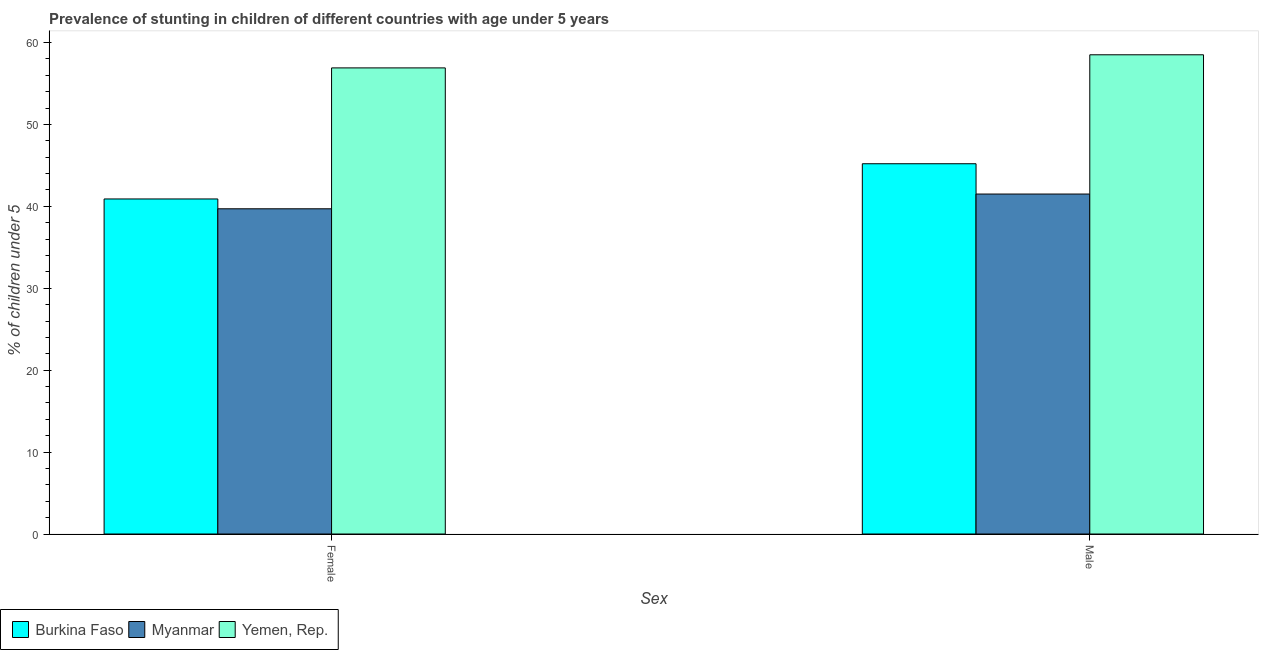How many different coloured bars are there?
Give a very brief answer. 3. Are the number of bars per tick equal to the number of legend labels?
Give a very brief answer. Yes. How many bars are there on the 1st tick from the left?
Give a very brief answer. 3. How many bars are there on the 1st tick from the right?
Provide a succinct answer. 3. What is the percentage of stunted male children in Yemen, Rep.?
Ensure brevity in your answer.  58.5. Across all countries, what is the maximum percentage of stunted female children?
Offer a very short reply. 56.9. Across all countries, what is the minimum percentage of stunted male children?
Offer a terse response. 41.5. In which country was the percentage of stunted female children maximum?
Offer a terse response. Yemen, Rep. In which country was the percentage of stunted female children minimum?
Make the answer very short. Myanmar. What is the total percentage of stunted female children in the graph?
Make the answer very short. 137.5. What is the difference between the percentage of stunted male children in Yemen, Rep. and that in Burkina Faso?
Provide a succinct answer. 13.3. What is the difference between the percentage of stunted female children in Yemen, Rep. and the percentage of stunted male children in Burkina Faso?
Ensure brevity in your answer.  11.7. What is the average percentage of stunted male children per country?
Keep it short and to the point. 48.4. What is the difference between the percentage of stunted male children and percentage of stunted female children in Myanmar?
Your answer should be compact. 1.8. In how many countries, is the percentage of stunted male children greater than 54 %?
Your response must be concise. 1. What is the ratio of the percentage of stunted female children in Burkina Faso to that in Yemen, Rep.?
Offer a terse response. 0.72. Is the percentage of stunted male children in Burkina Faso less than that in Myanmar?
Give a very brief answer. No. What does the 2nd bar from the left in Female represents?
Give a very brief answer. Myanmar. What does the 3rd bar from the right in Male represents?
Give a very brief answer. Burkina Faso. Are all the bars in the graph horizontal?
Give a very brief answer. No. How many countries are there in the graph?
Give a very brief answer. 3. What is the difference between two consecutive major ticks on the Y-axis?
Your response must be concise. 10. Are the values on the major ticks of Y-axis written in scientific E-notation?
Keep it short and to the point. No. Does the graph contain any zero values?
Give a very brief answer. No. Does the graph contain grids?
Keep it short and to the point. No. Where does the legend appear in the graph?
Offer a very short reply. Bottom left. How many legend labels are there?
Your response must be concise. 3. How are the legend labels stacked?
Your response must be concise. Horizontal. What is the title of the graph?
Provide a succinct answer. Prevalence of stunting in children of different countries with age under 5 years. Does "Low income" appear as one of the legend labels in the graph?
Offer a very short reply. No. What is the label or title of the X-axis?
Give a very brief answer. Sex. What is the label or title of the Y-axis?
Provide a short and direct response.  % of children under 5. What is the  % of children under 5 of Burkina Faso in Female?
Provide a short and direct response. 40.9. What is the  % of children under 5 of Myanmar in Female?
Offer a very short reply. 39.7. What is the  % of children under 5 in Yemen, Rep. in Female?
Provide a short and direct response. 56.9. What is the  % of children under 5 of Burkina Faso in Male?
Offer a terse response. 45.2. What is the  % of children under 5 in Myanmar in Male?
Provide a succinct answer. 41.5. What is the  % of children under 5 of Yemen, Rep. in Male?
Provide a succinct answer. 58.5. Across all Sex, what is the maximum  % of children under 5 of Burkina Faso?
Offer a terse response. 45.2. Across all Sex, what is the maximum  % of children under 5 of Myanmar?
Make the answer very short. 41.5. Across all Sex, what is the maximum  % of children under 5 of Yemen, Rep.?
Your answer should be very brief. 58.5. Across all Sex, what is the minimum  % of children under 5 of Burkina Faso?
Your answer should be compact. 40.9. Across all Sex, what is the minimum  % of children under 5 in Myanmar?
Make the answer very short. 39.7. Across all Sex, what is the minimum  % of children under 5 in Yemen, Rep.?
Offer a very short reply. 56.9. What is the total  % of children under 5 of Burkina Faso in the graph?
Keep it short and to the point. 86.1. What is the total  % of children under 5 of Myanmar in the graph?
Offer a very short reply. 81.2. What is the total  % of children under 5 of Yemen, Rep. in the graph?
Provide a succinct answer. 115.4. What is the difference between the  % of children under 5 in Burkina Faso in Female and the  % of children under 5 in Myanmar in Male?
Your response must be concise. -0.6. What is the difference between the  % of children under 5 of Burkina Faso in Female and the  % of children under 5 of Yemen, Rep. in Male?
Offer a very short reply. -17.6. What is the difference between the  % of children under 5 in Myanmar in Female and the  % of children under 5 in Yemen, Rep. in Male?
Offer a terse response. -18.8. What is the average  % of children under 5 in Burkina Faso per Sex?
Your answer should be very brief. 43.05. What is the average  % of children under 5 in Myanmar per Sex?
Offer a very short reply. 40.6. What is the average  % of children under 5 of Yemen, Rep. per Sex?
Give a very brief answer. 57.7. What is the difference between the  % of children under 5 of Burkina Faso and  % of children under 5 of Yemen, Rep. in Female?
Your response must be concise. -16. What is the difference between the  % of children under 5 in Myanmar and  % of children under 5 in Yemen, Rep. in Female?
Make the answer very short. -17.2. What is the difference between the  % of children under 5 of Burkina Faso and  % of children under 5 of Myanmar in Male?
Ensure brevity in your answer.  3.7. What is the difference between the  % of children under 5 in Burkina Faso and  % of children under 5 in Yemen, Rep. in Male?
Make the answer very short. -13.3. What is the difference between the  % of children under 5 in Myanmar and  % of children under 5 in Yemen, Rep. in Male?
Provide a short and direct response. -17. What is the ratio of the  % of children under 5 of Burkina Faso in Female to that in Male?
Your answer should be very brief. 0.9. What is the ratio of the  % of children under 5 in Myanmar in Female to that in Male?
Ensure brevity in your answer.  0.96. What is the ratio of the  % of children under 5 of Yemen, Rep. in Female to that in Male?
Your response must be concise. 0.97. What is the difference between the highest and the second highest  % of children under 5 in Yemen, Rep.?
Provide a short and direct response. 1.6. What is the difference between the highest and the lowest  % of children under 5 of Burkina Faso?
Keep it short and to the point. 4.3. 